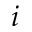Convert formula to latex. <formula><loc_0><loc_0><loc_500><loc_500>i</formula> 